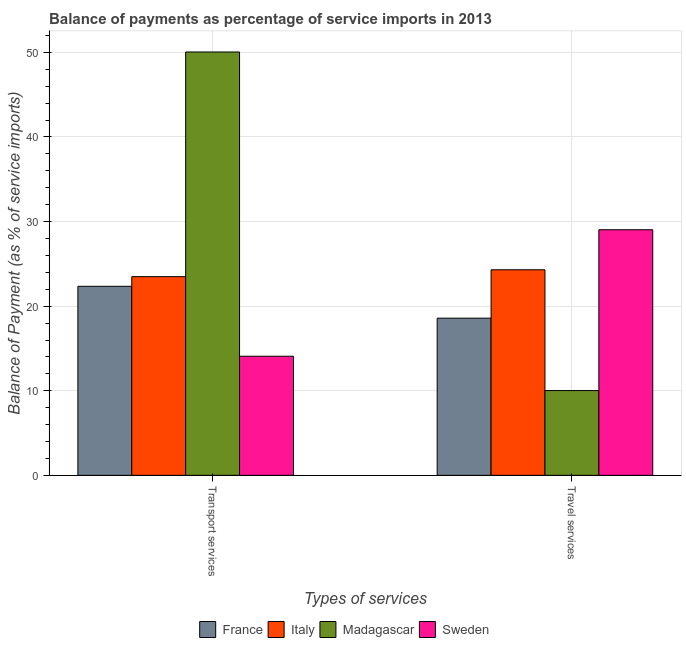How many different coloured bars are there?
Offer a very short reply. 4. How many groups of bars are there?
Keep it short and to the point. 2. Are the number of bars per tick equal to the number of legend labels?
Keep it short and to the point. Yes. How many bars are there on the 1st tick from the right?
Give a very brief answer. 4. What is the label of the 2nd group of bars from the left?
Offer a terse response. Travel services. What is the balance of payments of travel services in Madagascar?
Your response must be concise. 10.02. Across all countries, what is the maximum balance of payments of travel services?
Offer a very short reply. 29.03. Across all countries, what is the minimum balance of payments of transport services?
Your answer should be very brief. 14.08. In which country was the balance of payments of transport services maximum?
Offer a very short reply. Madagascar. In which country was the balance of payments of travel services minimum?
Your answer should be very brief. Madagascar. What is the total balance of payments of travel services in the graph?
Provide a short and direct response. 81.94. What is the difference between the balance of payments of travel services in Sweden and that in Italy?
Your answer should be compact. 4.73. What is the difference between the balance of payments of travel services in Italy and the balance of payments of transport services in Sweden?
Your answer should be compact. 10.22. What is the average balance of payments of travel services per country?
Provide a succinct answer. 20.49. What is the difference between the balance of payments of transport services and balance of payments of travel services in France?
Keep it short and to the point. 3.77. What is the ratio of the balance of payments of transport services in Sweden to that in France?
Provide a succinct answer. 0.63. Is the balance of payments of transport services in France less than that in Madagascar?
Offer a terse response. Yes. Are the values on the major ticks of Y-axis written in scientific E-notation?
Provide a succinct answer. No. Does the graph contain grids?
Give a very brief answer. Yes. What is the title of the graph?
Your answer should be very brief. Balance of payments as percentage of service imports in 2013. What is the label or title of the X-axis?
Offer a very short reply. Types of services. What is the label or title of the Y-axis?
Make the answer very short. Balance of Payment (as % of service imports). What is the Balance of Payment (as % of service imports) of France in Transport services?
Your answer should be very brief. 22.35. What is the Balance of Payment (as % of service imports) of Italy in Transport services?
Ensure brevity in your answer.  23.49. What is the Balance of Payment (as % of service imports) in Madagascar in Transport services?
Provide a succinct answer. 50.05. What is the Balance of Payment (as % of service imports) in Sweden in Transport services?
Offer a terse response. 14.08. What is the Balance of Payment (as % of service imports) in France in Travel services?
Your answer should be compact. 18.58. What is the Balance of Payment (as % of service imports) in Italy in Travel services?
Your answer should be compact. 24.3. What is the Balance of Payment (as % of service imports) of Madagascar in Travel services?
Ensure brevity in your answer.  10.02. What is the Balance of Payment (as % of service imports) of Sweden in Travel services?
Give a very brief answer. 29.03. Across all Types of services, what is the maximum Balance of Payment (as % of service imports) in France?
Provide a short and direct response. 22.35. Across all Types of services, what is the maximum Balance of Payment (as % of service imports) in Italy?
Your answer should be compact. 24.3. Across all Types of services, what is the maximum Balance of Payment (as % of service imports) in Madagascar?
Make the answer very short. 50.05. Across all Types of services, what is the maximum Balance of Payment (as % of service imports) in Sweden?
Provide a succinct answer. 29.03. Across all Types of services, what is the minimum Balance of Payment (as % of service imports) in France?
Give a very brief answer. 18.58. Across all Types of services, what is the minimum Balance of Payment (as % of service imports) in Italy?
Make the answer very short. 23.49. Across all Types of services, what is the minimum Balance of Payment (as % of service imports) in Madagascar?
Your response must be concise. 10.02. Across all Types of services, what is the minimum Balance of Payment (as % of service imports) of Sweden?
Provide a succinct answer. 14.08. What is the total Balance of Payment (as % of service imports) of France in the graph?
Make the answer very short. 40.93. What is the total Balance of Payment (as % of service imports) of Italy in the graph?
Offer a terse response. 47.79. What is the total Balance of Payment (as % of service imports) in Madagascar in the graph?
Give a very brief answer. 60.07. What is the total Balance of Payment (as % of service imports) of Sweden in the graph?
Keep it short and to the point. 43.11. What is the difference between the Balance of Payment (as % of service imports) of France in Transport services and that in Travel services?
Offer a terse response. 3.77. What is the difference between the Balance of Payment (as % of service imports) of Italy in Transport services and that in Travel services?
Your response must be concise. -0.81. What is the difference between the Balance of Payment (as % of service imports) in Madagascar in Transport services and that in Travel services?
Provide a short and direct response. 40.03. What is the difference between the Balance of Payment (as % of service imports) in Sweden in Transport services and that in Travel services?
Ensure brevity in your answer.  -14.96. What is the difference between the Balance of Payment (as % of service imports) in France in Transport services and the Balance of Payment (as % of service imports) in Italy in Travel services?
Your answer should be very brief. -1.95. What is the difference between the Balance of Payment (as % of service imports) of France in Transport services and the Balance of Payment (as % of service imports) of Madagascar in Travel services?
Provide a succinct answer. 12.33. What is the difference between the Balance of Payment (as % of service imports) in France in Transport services and the Balance of Payment (as % of service imports) in Sweden in Travel services?
Keep it short and to the point. -6.69. What is the difference between the Balance of Payment (as % of service imports) of Italy in Transport services and the Balance of Payment (as % of service imports) of Madagascar in Travel services?
Provide a short and direct response. 13.47. What is the difference between the Balance of Payment (as % of service imports) of Italy in Transport services and the Balance of Payment (as % of service imports) of Sweden in Travel services?
Give a very brief answer. -5.55. What is the difference between the Balance of Payment (as % of service imports) of Madagascar in Transport services and the Balance of Payment (as % of service imports) of Sweden in Travel services?
Your answer should be very brief. 21.01. What is the average Balance of Payment (as % of service imports) in France per Types of services?
Provide a succinct answer. 20.46. What is the average Balance of Payment (as % of service imports) in Italy per Types of services?
Your response must be concise. 23.9. What is the average Balance of Payment (as % of service imports) of Madagascar per Types of services?
Give a very brief answer. 30.04. What is the average Balance of Payment (as % of service imports) in Sweden per Types of services?
Provide a short and direct response. 21.56. What is the difference between the Balance of Payment (as % of service imports) of France and Balance of Payment (as % of service imports) of Italy in Transport services?
Ensure brevity in your answer.  -1.14. What is the difference between the Balance of Payment (as % of service imports) in France and Balance of Payment (as % of service imports) in Madagascar in Transport services?
Your answer should be very brief. -27.7. What is the difference between the Balance of Payment (as % of service imports) in France and Balance of Payment (as % of service imports) in Sweden in Transport services?
Offer a terse response. 8.27. What is the difference between the Balance of Payment (as % of service imports) in Italy and Balance of Payment (as % of service imports) in Madagascar in Transport services?
Keep it short and to the point. -26.56. What is the difference between the Balance of Payment (as % of service imports) in Italy and Balance of Payment (as % of service imports) in Sweden in Transport services?
Provide a short and direct response. 9.41. What is the difference between the Balance of Payment (as % of service imports) of Madagascar and Balance of Payment (as % of service imports) of Sweden in Transport services?
Your answer should be compact. 35.97. What is the difference between the Balance of Payment (as % of service imports) in France and Balance of Payment (as % of service imports) in Italy in Travel services?
Provide a short and direct response. -5.72. What is the difference between the Balance of Payment (as % of service imports) in France and Balance of Payment (as % of service imports) in Madagascar in Travel services?
Make the answer very short. 8.56. What is the difference between the Balance of Payment (as % of service imports) of France and Balance of Payment (as % of service imports) of Sweden in Travel services?
Provide a succinct answer. -10.45. What is the difference between the Balance of Payment (as % of service imports) in Italy and Balance of Payment (as % of service imports) in Madagascar in Travel services?
Give a very brief answer. 14.28. What is the difference between the Balance of Payment (as % of service imports) of Italy and Balance of Payment (as % of service imports) of Sweden in Travel services?
Give a very brief answer. -4.73. What is the difference between the Balance of Payment (as % of service imports) of Madagascar and Balance of Payment (as % of service imports) of Sweden in Travel services?
Make the answer very short. -19.01. What is the ratio of the Balance of Payment (as % of service imports) in France in Transport services to that in Travel services?
Your response must be concise. 1.2. What is the ratio of the Balance of Payment (as % of service imports) in Italy in Transport services to that in Travel services?
Your answer should be very brief. 0.97. What is the ratio of the Balance of Payment (as % of service imports) in Madagascar in Transport services to that in Travel services?
Give a very brief answer. 4.99. What is the ratio of the Balance of Payment (as % of service imports) of Sweden in Transport services to that in Travel services?
Offer a terse response. 0.48. What is the difference between the highest and the second highest Balance of Payment (as % of service imports) of France?
Give a very brief answer. 3.77. What is the difference between the highest and the second highest Balance of Payment (as % of service imports) of Italy?
Keep it short and to the point. 0.81. What is the difference between the highest and the second highest Balance of Payment (as % of service imports) in Madagascar?
Provide a short and direct response. 40.03. What is the difference between the highest and the second highest Balance of Payment (as % of service imports) in Sweden?
Make the answer very short. 14.96. What is the difference between the highest and the lowest Balance of Payment (as % of service imports) of France?
Make the answer very short. 3.77. What is the difference between the highest and the lowest Balance of Payment (as % of service imports) in Italy?
Give a very brief answer. 0.81. What is the difference between the highest and the lowest Balance of Payment (as % of service imports) of Madagascar?
Offer a very short reply. 40.03. What is the difference between the highest and the lowest Balance of Payment (as % of service imports) of Sweden?
Ensure brevity in your answer.  14.96. 